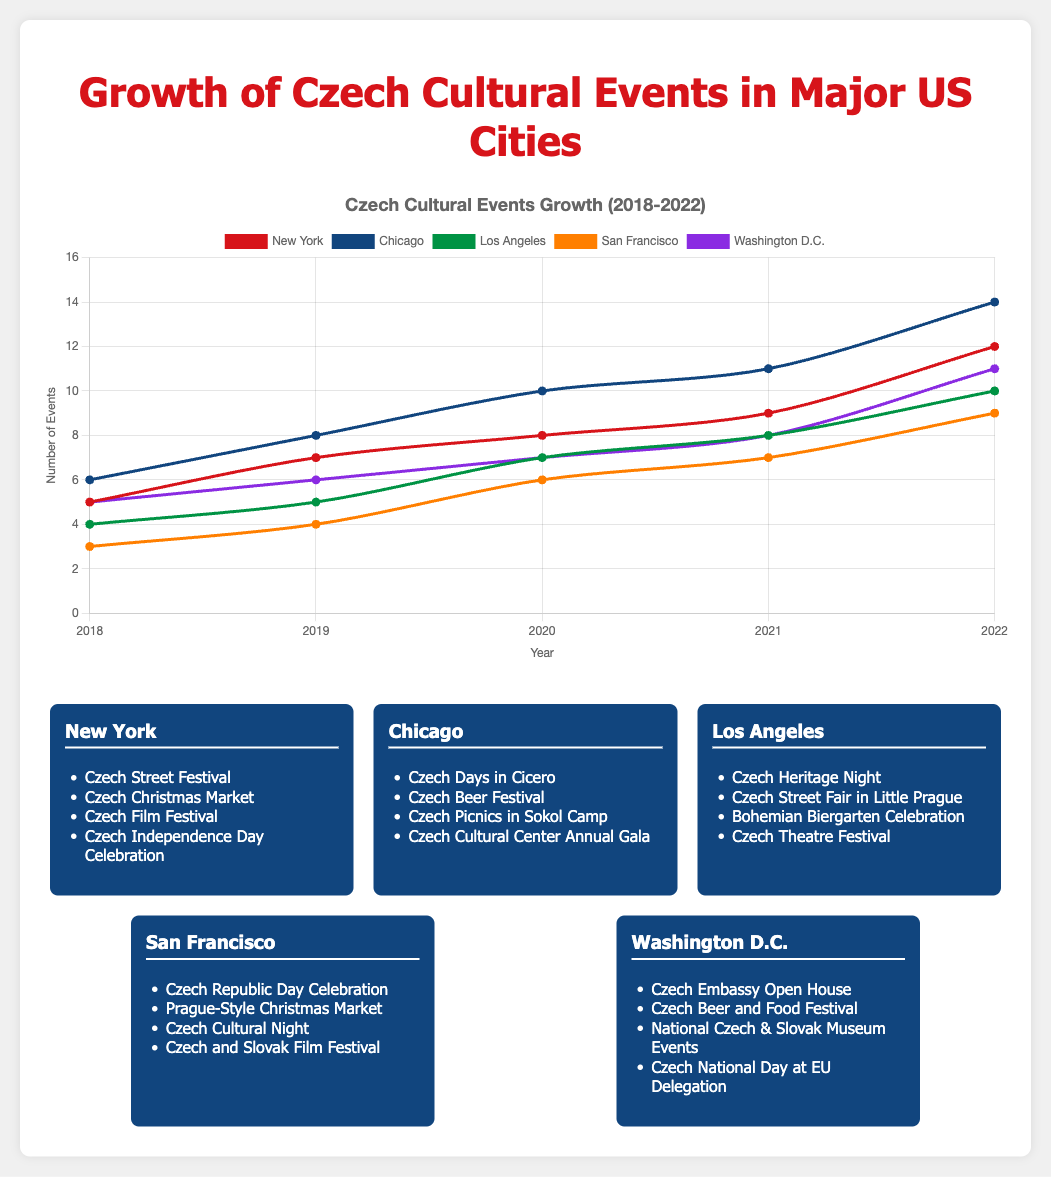Which city had the highest number of Czech cultural events in 2022? Look at the data for each city in 2022. New York had 12 events, Chicago had 14, Los Angeles had 10, San Francisco had 9, and Washington D.C. had 11. Chicago had the highest number.
Answer: Chicago How many total Czech cultural events were held in New York over the five years? Add the number of events in New York for each year: 5 (2018) + 7 (2019) + 8 (2020) + 9 (2021) + 12 (2022) = 41 events.
Answer: 41 Between 2019 and 2020, which city had the largest increase in the number of events? Calculate the difference in the number of events for each city from 2019 to 2020. New York: 8 - 7 = 1, Chicago: 10 - 8 = 2, Los Angeles: 7 - 5 = 2, San Francisco: 6 - 4 = 2, Washington D.C.: 7 - 6 = 1. Chicago, Los Angeles, and San Francisco all had the largest increase with an increase of 2 events each.
Answer: Chicago, Los Angeles, San Francisco Which year's data shows the largest overall number of events across all cities combined? Add the number of events for all cities for each year and compare. 2018: 5+6+4+3+5=23; 2019: 7+8+5+4+6=30; 2020: 8+10+7+6+7=38; 2021: 9+11+8+7+8=43; 2022: 12+14+10+9+11=56. The year 2022 shows the largest overall number of events.
Answer: 2022 Which city had the lowest number of events in 2018? Compare the number of events in 2018: New York 5, Chicago 6, Los Angeles 4, San Francisco 3, Washington D.C. 5. San Francisco had the lowest number of events.
Answer: San Francisco What is the average number of events held in Los Angeles per year over the five-year period? Add the number of events in Los Angeles for each year and divide by 5: (4 + 5 + 7 + 8 + 10) / 5 = 34 / 5 = 6.8.
Answer: 6.8 In which year did Washington D.C. see the smallest increase in the number of events compared to the previous year? Calculate the differences between each consecutive year for Washington D.C.: 6 - 5 = 1 (2019), 7 - 6 = 1 (2020), 8 - 7 = 1 (2021), 11 - 8 = 3 (2022). The years 2019, 2020, and 2021 had the smallest increases of 1 event each.
Answer: 2019, 2020, 2021 